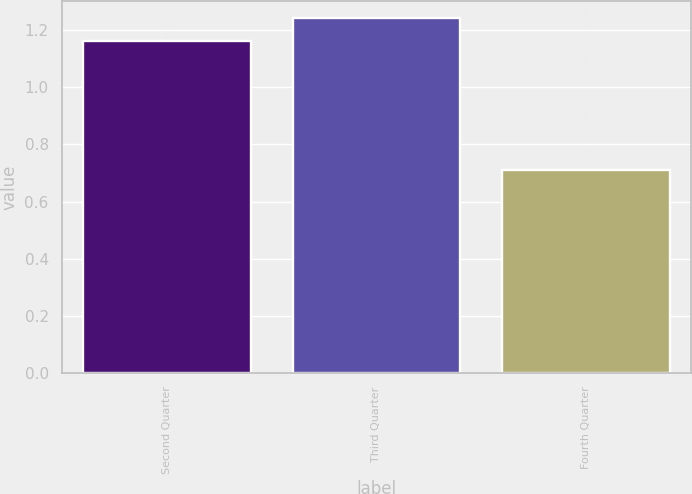<chart> <loc_0><loc_0><loc_500><loc_500><bar_chart><fcel>Second Quarter<fcel>Third Quarter<fcel>Fourth Quarter<nl><fcel>1.16<fcel>1.24<fcel>0.71<nl></chart> 